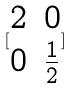Convert formula to latex. <formula><loc_0><loc_0><loc_500><loc_500>[ \begin{matrix} 2 & 0 \\ 0 & \frac { 1 } { 2 } \end{matrix} ]</formula> 